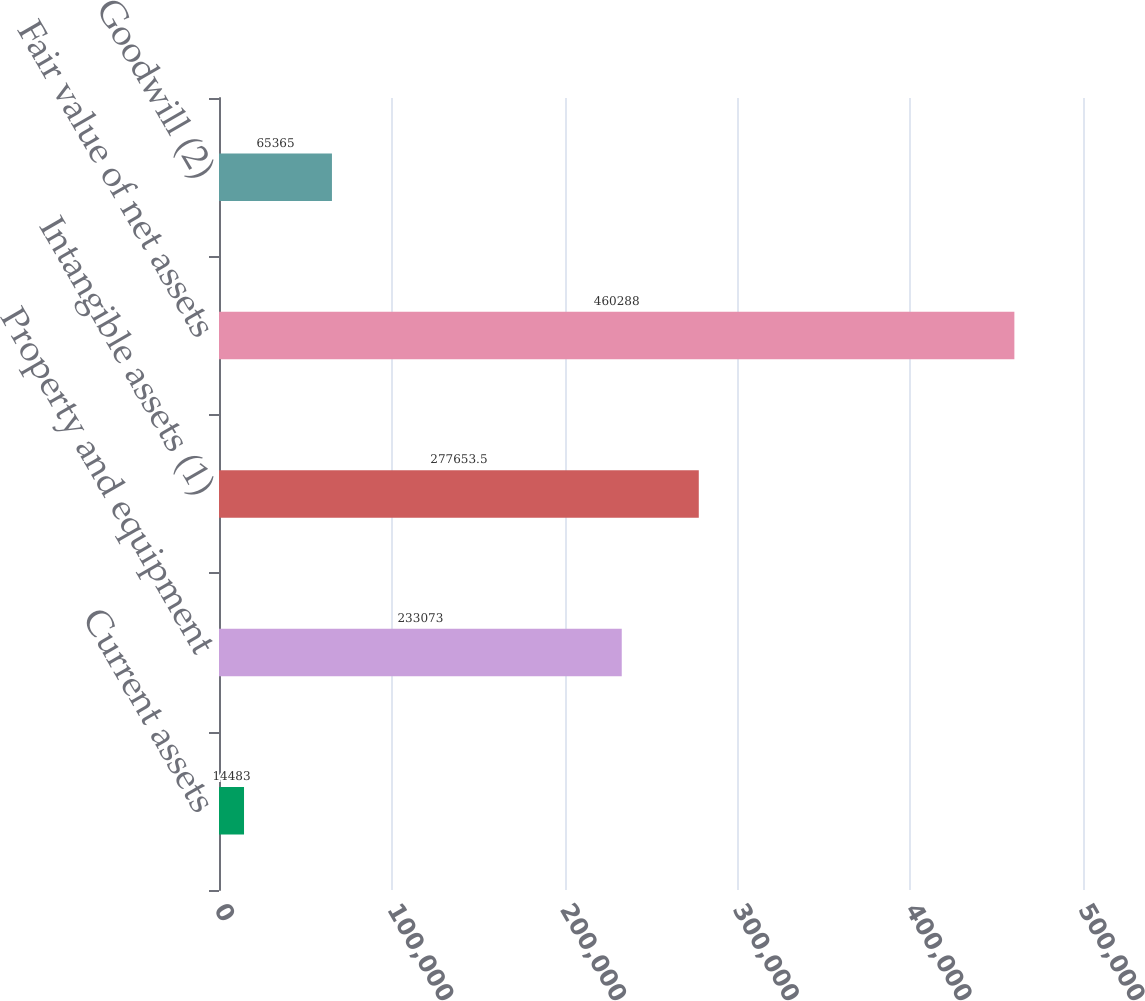Convert chart to OTSL. <chart><loc_0><loc_0><loc_500><loc_500><bar_chart><fcel>Current assets<fcel>Property and equipment<fcel>Intangible assets (1)<fcel>Fair value of net assets<fcel>Goodwill (2)<nl><fcel>14483<fcel>233073<fcel>277654<fcel>460288<fcel>65365<nl></chart> 